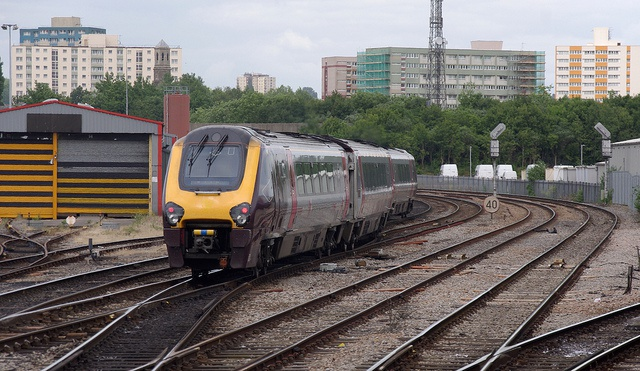Describe the objects in this image and their specific colors. I can see a train in lavender, gray, black, and darkgray tones in this image. 